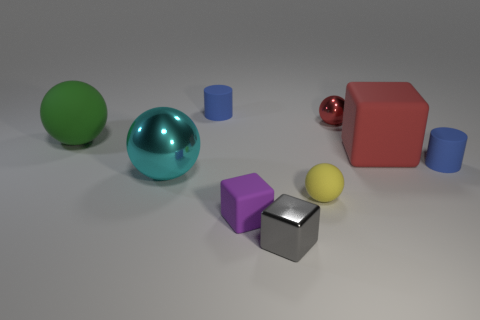How many brown things are either tiny cylinders or tiny rubber objects?
Offer a terse response. 0. The yellow sphere that is the same material as the purple cube is what size?
Offer a very short reply. Small. Is the material of the cylinder that is to the right of the red rubber object the same as the tiny blue cylinder left of the tiny metal cube?
Your answer should be compact. Yes. How many spheres are large red objects or blue things?
Make the answer very short. 0. What number of metal blocks are in front of the tiny gray metal object that is on the right side of the tiny blue matte cylinder on the left side of the small shiny cube?
Your answer should be very brief. 0. What material is the tiny gray object that is the same shape as the big red rubber thing?
Your answer should be compact. Metal. Is there anything else that is made of the same material as the gray object?
Give a very brief answer. Yes. The matte sphere on the left side of the cyan object is what color?
Provide a succinct answer. Green. Does the small gray cube have the same material as the red object that is to the right of the small red shiny sphere?
Your answer should be compact. No. What is the yellow ball made of?
Offer a terse response. Rubber. 